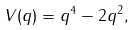<formula> <loc_0><loc_0><loc_500><loc_500>V ( q ) = q ^ { 4 } - 2 q ^ { 2 } ,</formula> 